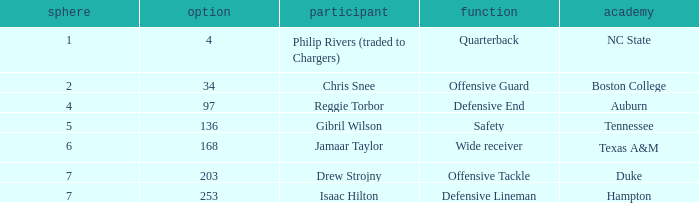Which Position has a Player of gibril wilson? Safety. 